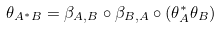Convert formula to latex. <formula><loc_0><loc_0><loc_500><loc_500>\theta _ { A ^ { * } B } = \beta _ { A , B } \circ \beta _ { B , A } \circ ( \theta _ { A } ^ { * } \theta _ { B } )</formula> 